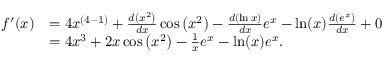<formula> <loc_0><loc_0><loc_500><loc_500>{ \begin{array} { r l } { f ^ { \prime } ( x ) } & { = 4 x ^ { ( 4 - 1 ) } + { \frac { d \left ( x ^ { 2 } \right ) } { d x } } \cos \left ( x ^ { 2 } \right ) - { \frac { d \left ( \ln { x } \right ) } { d x } } e ^ { x } - \ln ( x ) { \frac { d \left ( e ^ { x } \right ) } { d x } } + 0 } \\ & { = 4 x ^ { 3 } + 2 x \cos \left ( x ^ { 2 } \right ) - { \frac { 1 } { x } } e ^ { x } - \ln ( x ) e ^ { x } . } \end{array} }</formula> 